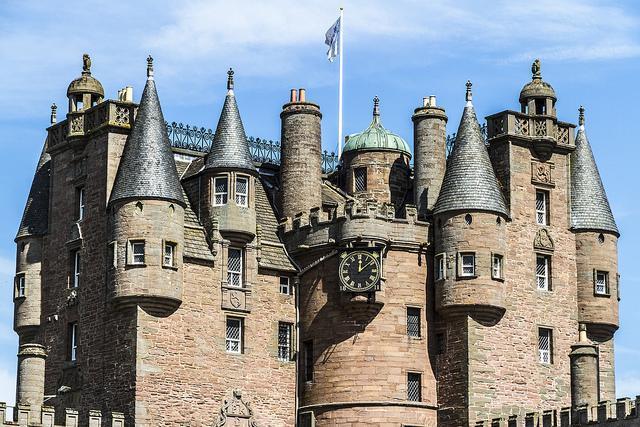How many flags are on this castle?
Give a very brief answer. 1. How many horses are in the picture?
Give a very brief answer. 0. 